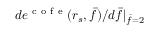<formula> <loc_0><loc_0><loc_500><loc_500>d e ^ { c o f e } ( r _ { s } , \bar { f } ) / d \bar { f } | _ { \bar { f } = 2 }</formula> 